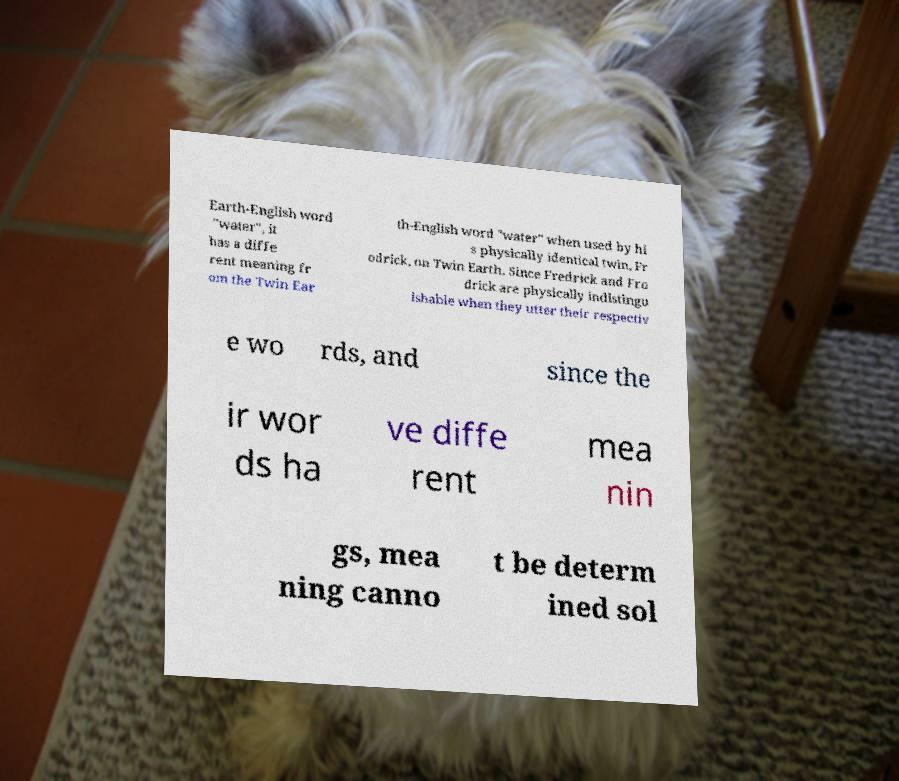Please identify and transcribe the text found in this image. Earth-English word "water", it has a diffe rent meaning fr om the Twin Ear th-English word "water" when used by hi s physically identical twin, Fr odrick, on Twin Earth. Since Fredrick and Fro drick are physically indistingu ishable when they utter their respectiv e wo rds, and since the ir wor ds ha ve diffe rent mea nin gs, mea ning canno t be determ ined sol 